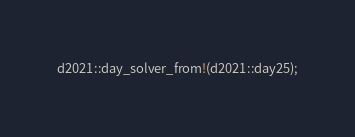Convert code to text. <code><loc_0><loc_0><loc_500><loc_500><_Rust_>d2021::day_solver_from!(d2021::day25);
</code> 